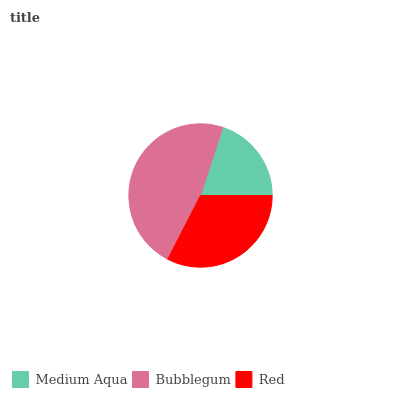Is Medium Aqua the minimum?
Answer yes or no. Yes. Is Bubblegum the maximum?
Answer yes or no. Yes. Is Red the minimum?
Answer yes or no. No. Is Red the maximum?
Answer yes or no. No. Is Bubblegum greater than Red?
Answer yes or no. Yes. Is Red less than Bubblegum?
Answer yes or no. Yes. Is Red greater than Bubblegum?
Answer yes or no. No. Is Bubblegum less than Red?
Answer yes or no. No. Is Red the high median?
Answer yes or no. Yes. Is Red the low median?
Answer yes or no. Yes. Is Medium Aqua the high median?
Answer yes or no. No. Is Medium Aqua the low median?
Answer yes or no. No. 